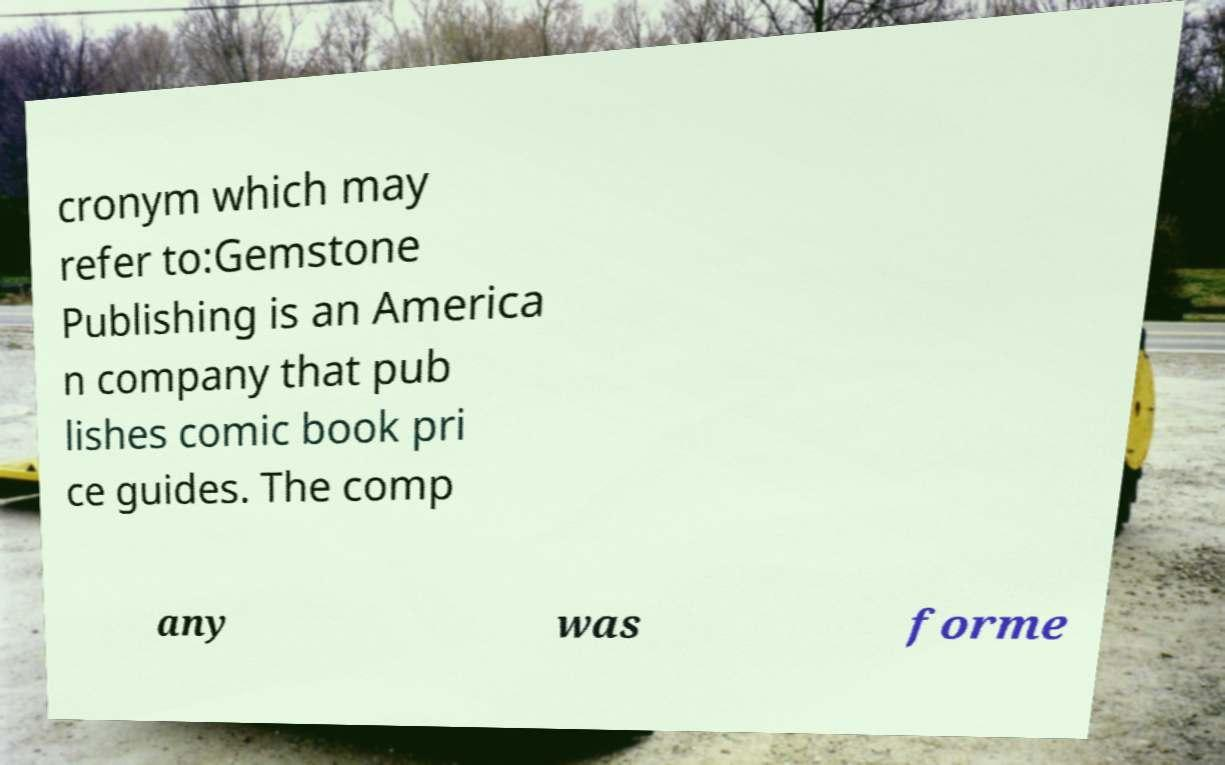There's text embedded in this image that I need extracted. Can you transcribe it verbatim? cronym which may refer to:Gemstone Publishing is an America n company that pub lishes comic book pri ce guides. The comp any was forme 